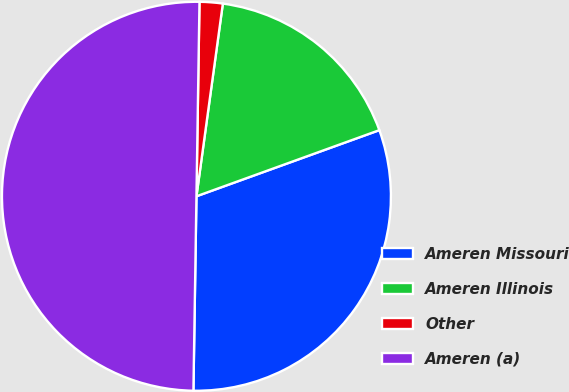<chart> <loc_0><loc_0><loc_500><loc_500><pie_chart><fcel>Ameren Missouri<fcel>Ameren Illinois<fcel>Other<fcel>Ameren (a)<nl><fcel>30.77%<fcel>17.31%<fcel>1.92%<fcel>50.0%<nl></chart> 